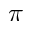Convert formula to latex. <formula><loc_0><loc_0><loc_500><loc_500>\pi</formula> 